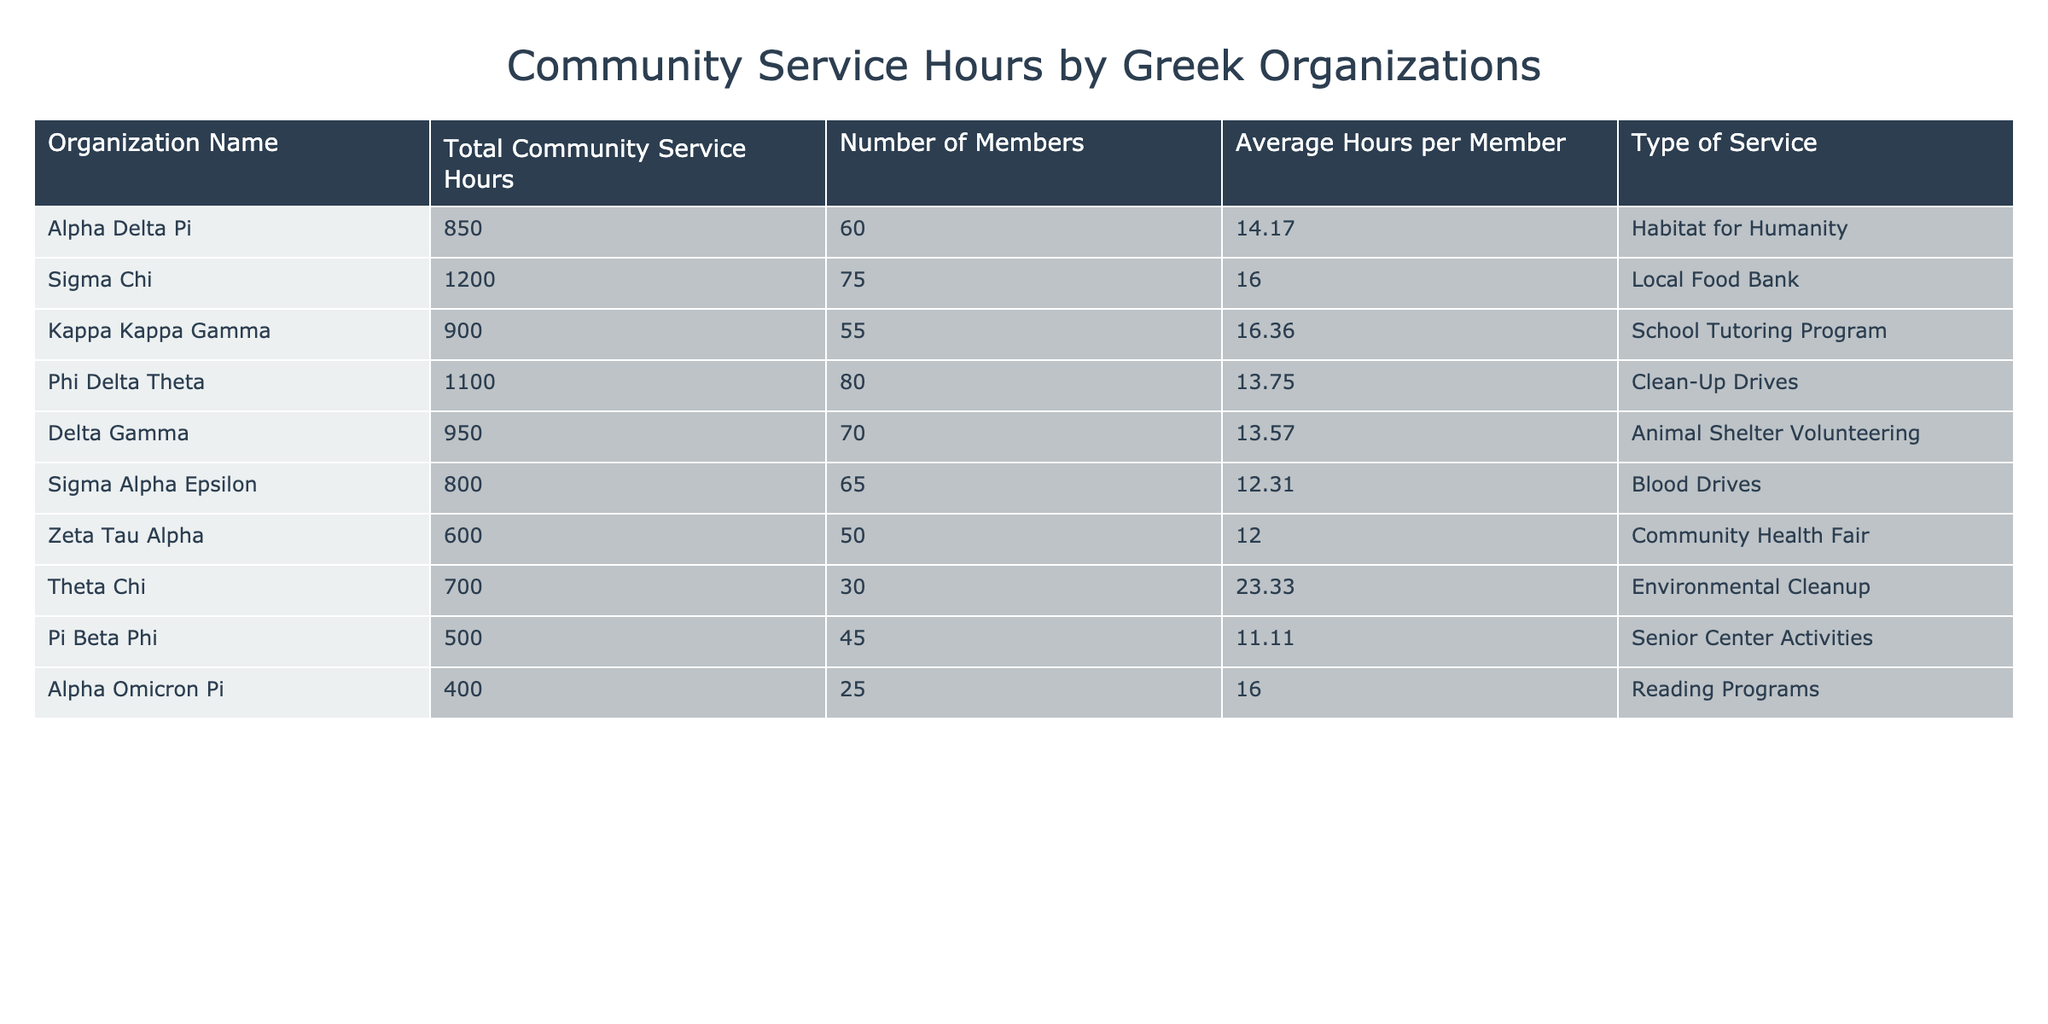What is the total number of community service hours contributed by Sigma Chi? According to the table, Sigma Chi contributed a total of 1200 community service hours.
Answer: 1200 Which organization has the highest average hours per member? By reviewing the average hours per member, Theta Chi has 23.33 hours, which is the highest compared to the others.
Answer: Theta Chi How many community service hours did Kappa Kappa Gamma contribute? Kappa Kappa Gamma contributed a total of 900 community service hours as indicated in the table.
Answer: 900 What is the total number of community service hours contributed by all organizations? By adding the total community service hours: 850 + 1200 + 900 + 1100 + 950 + 800 + 600 + 700 + 500 + 400 = 6550.
Answer: 6550 True or False: Zeta Tau Alpha has more total community service hours than Sigma Alpha Epsilon. Zeta Tau Alpha contributed 600 hours, while Sigma Alpha Epsilon contributed 800 hours, so the statement is false.
Answer: False Which organization contributed the least amount of community service hours? Pi Beta Phi contributed the least, with a total of 500 community service hours, as reflected in the table data.
Answer: Pi Beta Phi What is the average number of community service hours contributed by the organizations that are involved in school tutoring programs? Kappa Kappa Gamma contributed 900 hours, and the only other organization in a similar type is Alpha Omicron Pi with 400 hours, so the average is (900 + 400) / 2 = 650.
Answer: 650 If we compare the total service hours of Delta Gamma and Phi Delta Theta, who contributed more? Delta Gamma contributed 950 hours, while Phi Delta Theta contributed 1100 hours, showing that Phi Delta Theta contributed more.
Answer: Phi Delta Theta What percentage of the total community service hours did Alpha Delta Pi contribute? Alpha Delta Pi contributed 850 hours, and the total is 6550, so the percentage is (850 / 6550) * 100 ≈ 12.98%.
Answer: 12.98% If all organizations increase their community service hours by 10%, what would be the new total for Kappa Kappa Gamma? Kappa Kappa Gamma originally contributed 900 hours; with a 10% increase, the new total would be 900 + (10/100 * 900) = 990 hours.
Answer: 990 